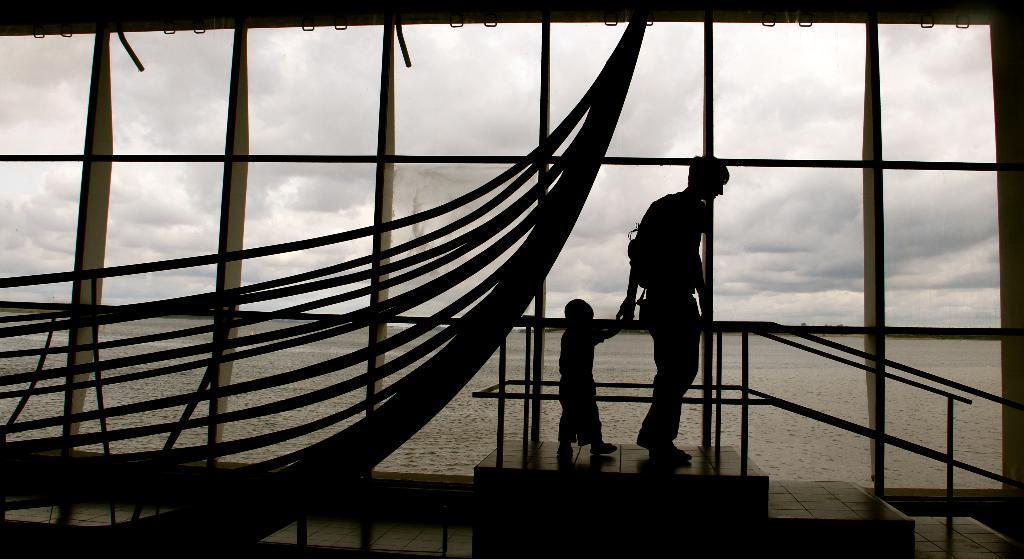Please provide a concise description of this image. In this image in the foreground there are some poles and one person is holding a baby and walking, and at the bottom there is a staircase and railing. On the left side there is a boat, and in the background there is a river and at the top of the image there is sky. 